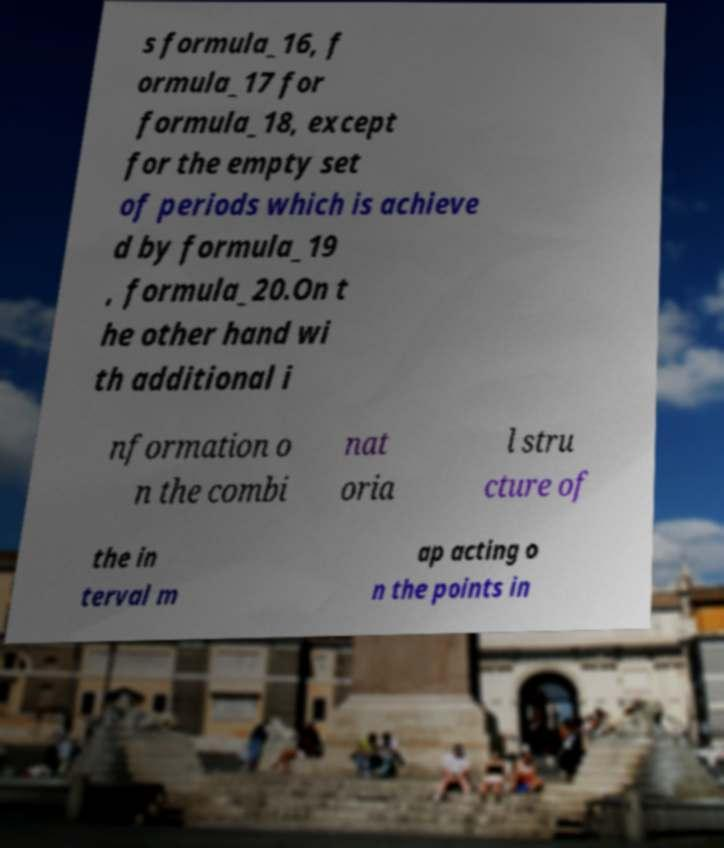What messages or text are displayed in this image? I need them in a readable, typed format. s formula_16, f ormula_17 for formula_18, except for the empty set of periods which is achieve d by formula_19 , formula_20.On t he other hand wi th additional i nformation o n the combi nat oria l stru cture of the in terval m ap acting o n the points in 